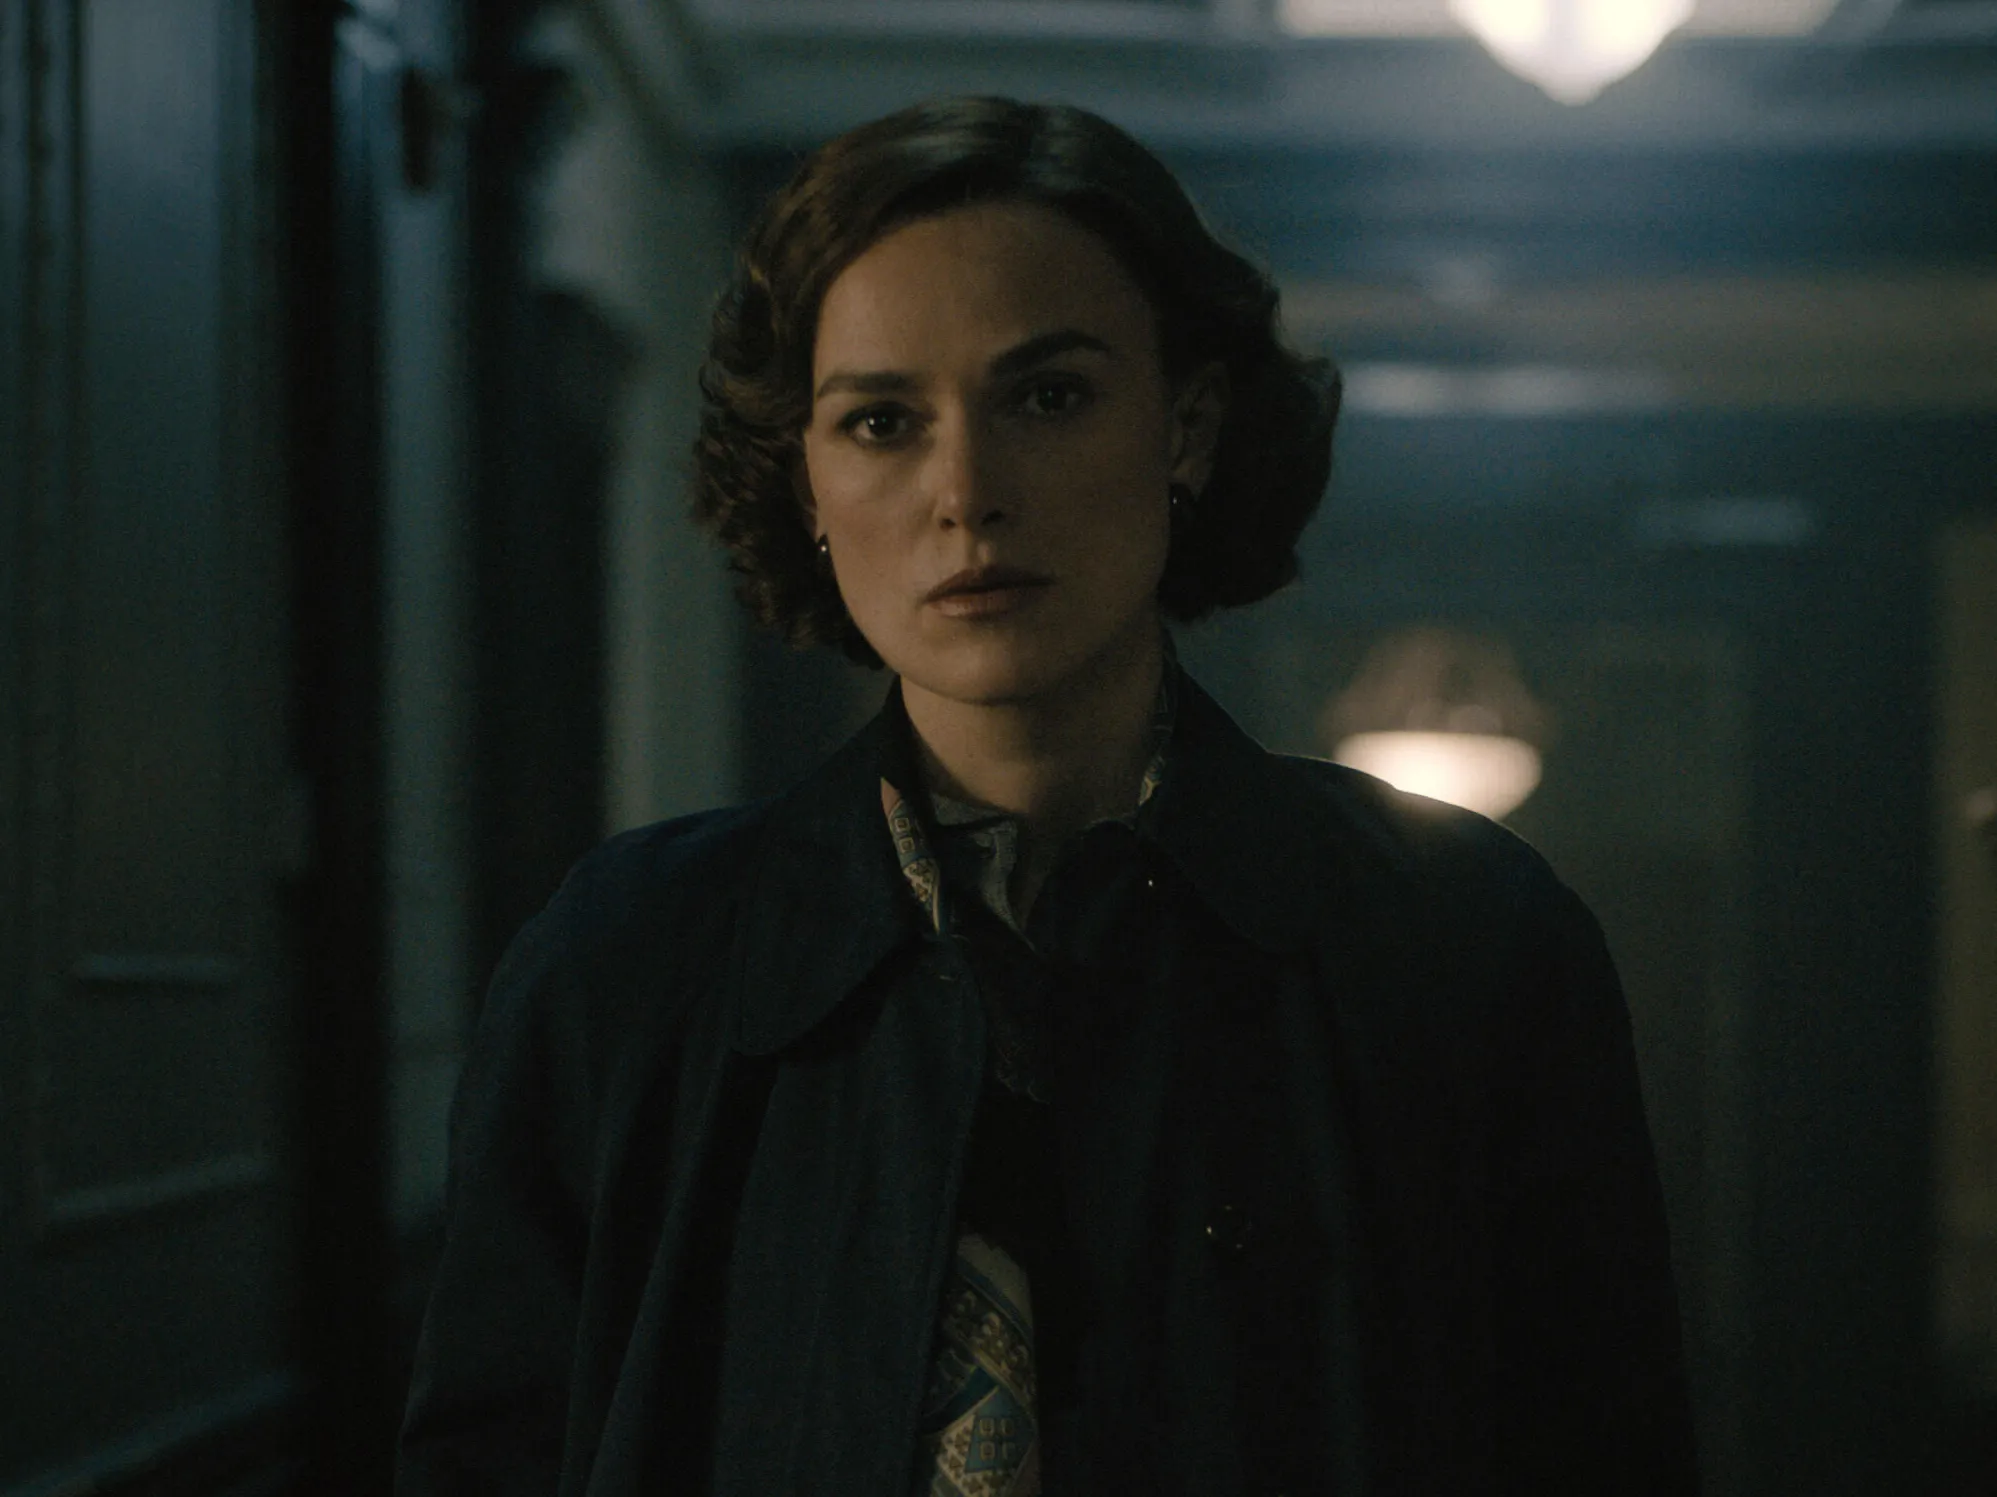What might be beyond the hallway? Beyond the hallway, one can imagine a variety of possibilities. It could lead to a series of interconnected rooms, each with its own story and secrets. Maybe there’s a grand library filled with ancient books and a roaring fireplace, or perhaps an elegant ballroom where a significant event has just taken place. Each turn and doorway might unravel more layers to the story, deepening the intrigue built by the woman’s expression and the hallway’s atmosphere. 